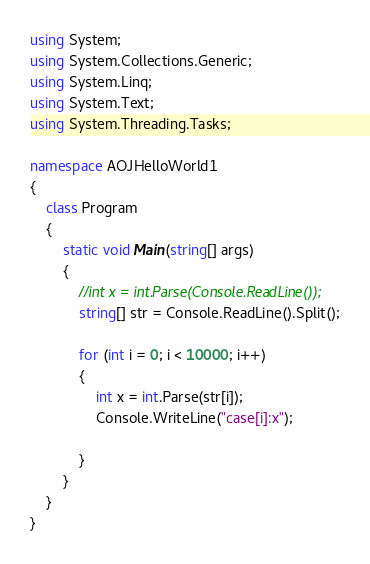Convert code to text. <code><loc_0><loc_0><loc_500><loc_500><_C#_>using System;
using System.Collections.Generic;
using System.Linq;
using System.Text;
using System.Threading.Tasks;

namespace AOJHelloWorld1
{
    class Program
    {
        static void Main(string[] args)
        {
            //int x = int.Parse(Console.ReadLine());
            string[] str = Console.ReadLine().Split();

            for (int i = 0; i < 10000; i++)
            {
                int x = int.Parse(str[i]);
                Console.WriteLine("case[i]:x");

            }
        }
    }
}

</code> 